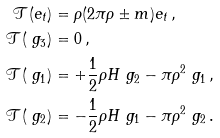Convert formula to latex. <formula><loc_0><loc_0><loc_500><loc_500>\mathcal { T } ( e _ { t } ) & = \rho ( 2 \pi \rho \pm m ) e _ { t } \, , \\ \mathcal { T } ( \ g _ { 3 } ) & = 0 \, , \\ \mathcal { T } ( \ g _ { 1 } ) & = + \frac { 1 } { 2 } \rho H \ g _ { 2 } - \pi \rho ^ { 2 } \ g _ { 1 } \, , \\ \mathcal { T } ( \ g _ { 2 } ) & = - \frac { 1 } { 2 } \rho H \ g _ { 1 } - \pi \rho ^ { 2 } \ g _ { 2 } \, .</formula> 